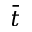<formula> <loc_0><loc_0><loc_500><loc_500>\bar { t }</formula> 